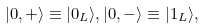<formula> <loc_0><loc_0><loc_500><loc_500>| 0 , + \rangle \equiv | 0 _ { L } \rangle , | 0 , - \rangle \equiv | 1 _ { L } \rangle ,</formula> 